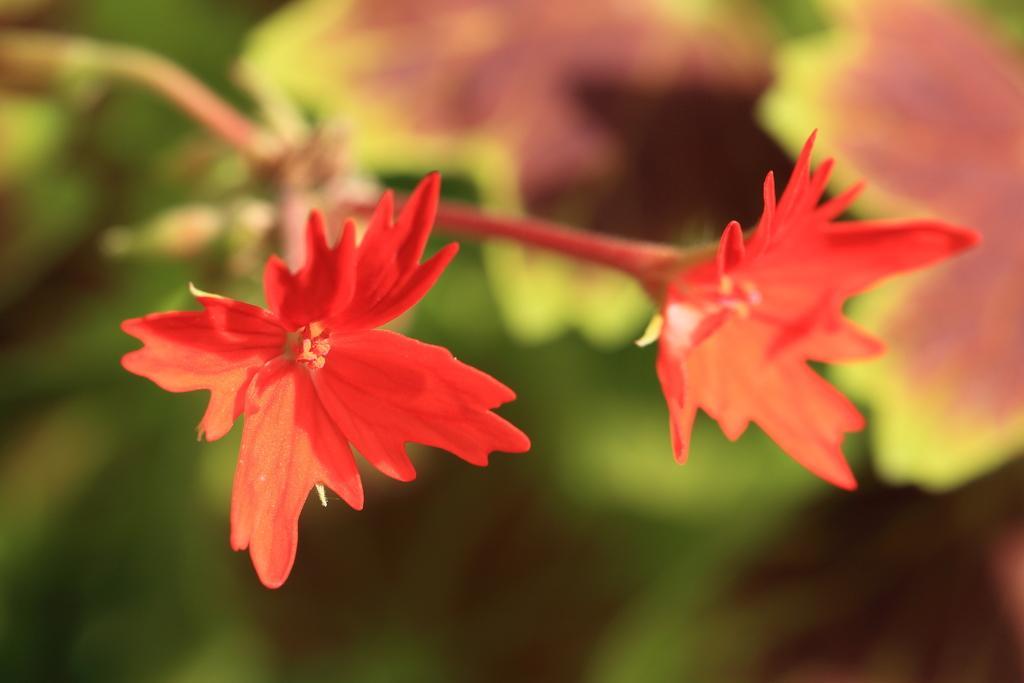Describe this image in one or two sentences. In this image, we can see flowers on blue background. 